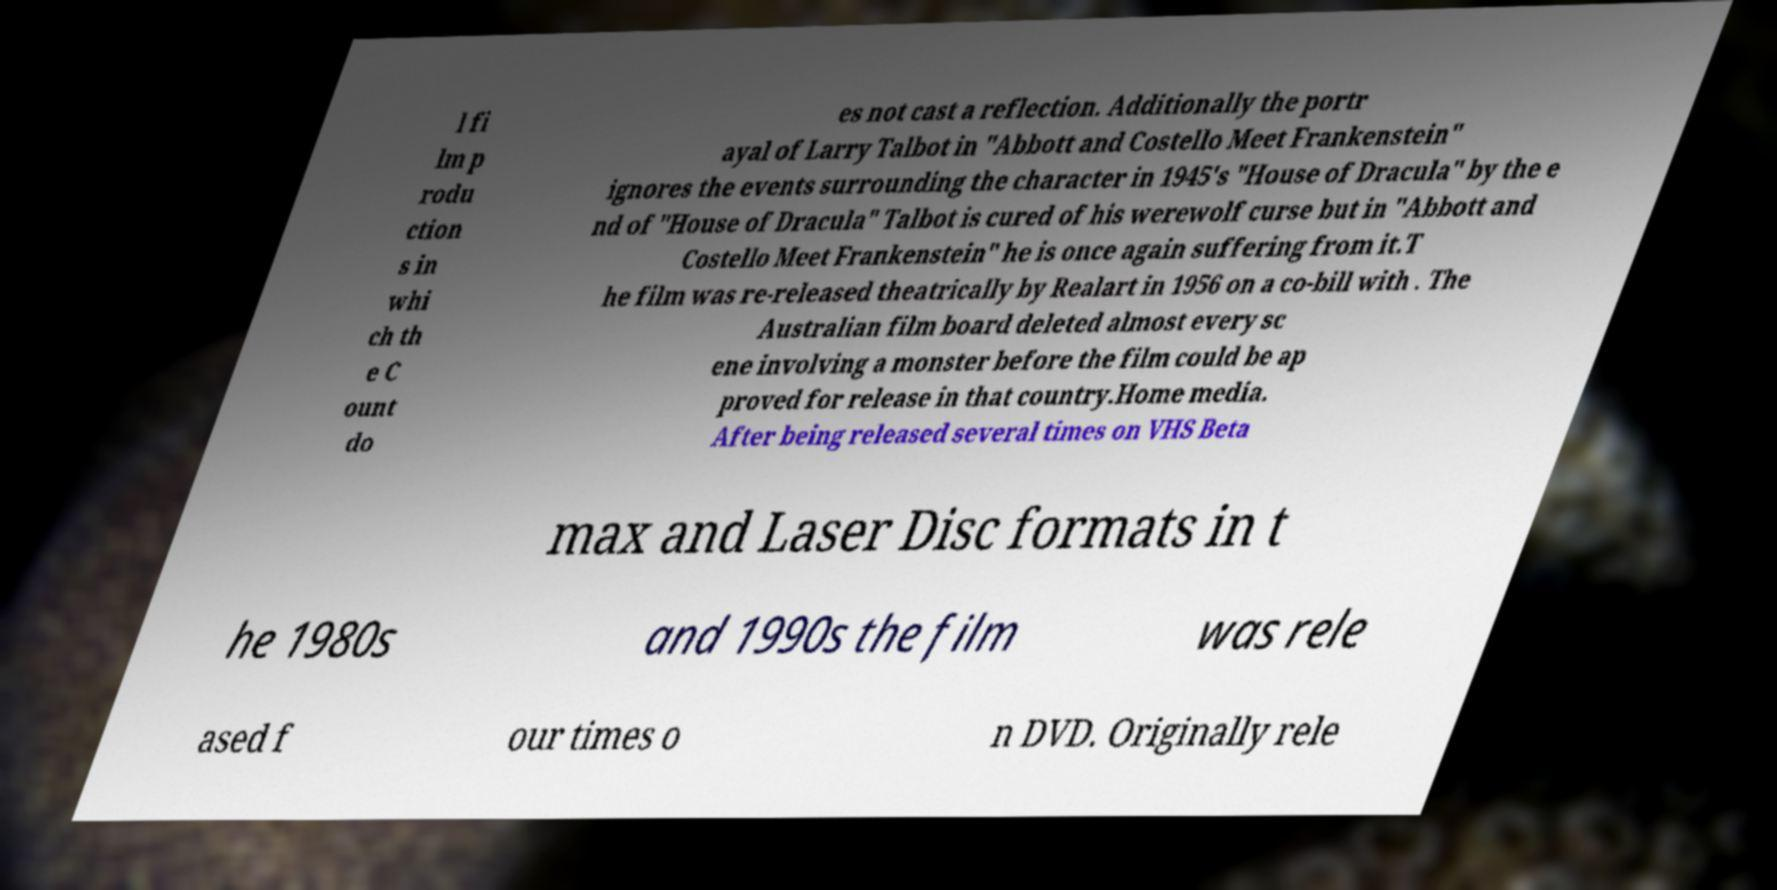For documentation purposes, I need the text within this image transcribed. Could you provide that? l fi lm p rodu ction s in whi ch th e C ount do es not cast a reflection. Additionally the portr ayal of Larry Talbot in "Abbott and Costello Meet Frankenstein" ignores the events surrounding the character in 1945's "House of Dracula" by the e nd of "House of Dracula" Talbot is cured of his werewolf curse but in "Abbott and Costello Meet Frankenstein" he is once again suffering from it.T he film was re-released theatrically by Realart in 1956 on a co-bill with . The Australian film board deleted almost every sc ene involving a monster before the film could be ap proved for release in that country.Home media. After being released several times on VHS Beta max and Laser Disc formats in t he 1980s and 1990s the film was rele ased f our times o n DVD. Originally rele 